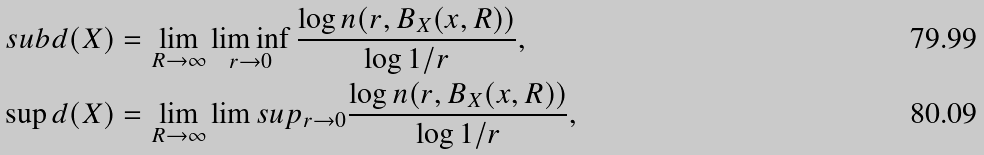Convert formula to latex. <formula><loc_0><loc_0><loc_500><loc_500>\ s u b d ( X ) & = \lim _ { R \to \infty } \liminf _ { r \to 0 } \frac { \log n ( r , B _ { X } ( x , R ) ) } { \log 1 / r } , \\ \sup d ( X ) & = \lim _ { R \to \infty } \lim s u p _ { r \to 0 } \frac { \log n ( r , B _ { X } ( x , R ) ) } { \log 1 / r } ,</formula> 